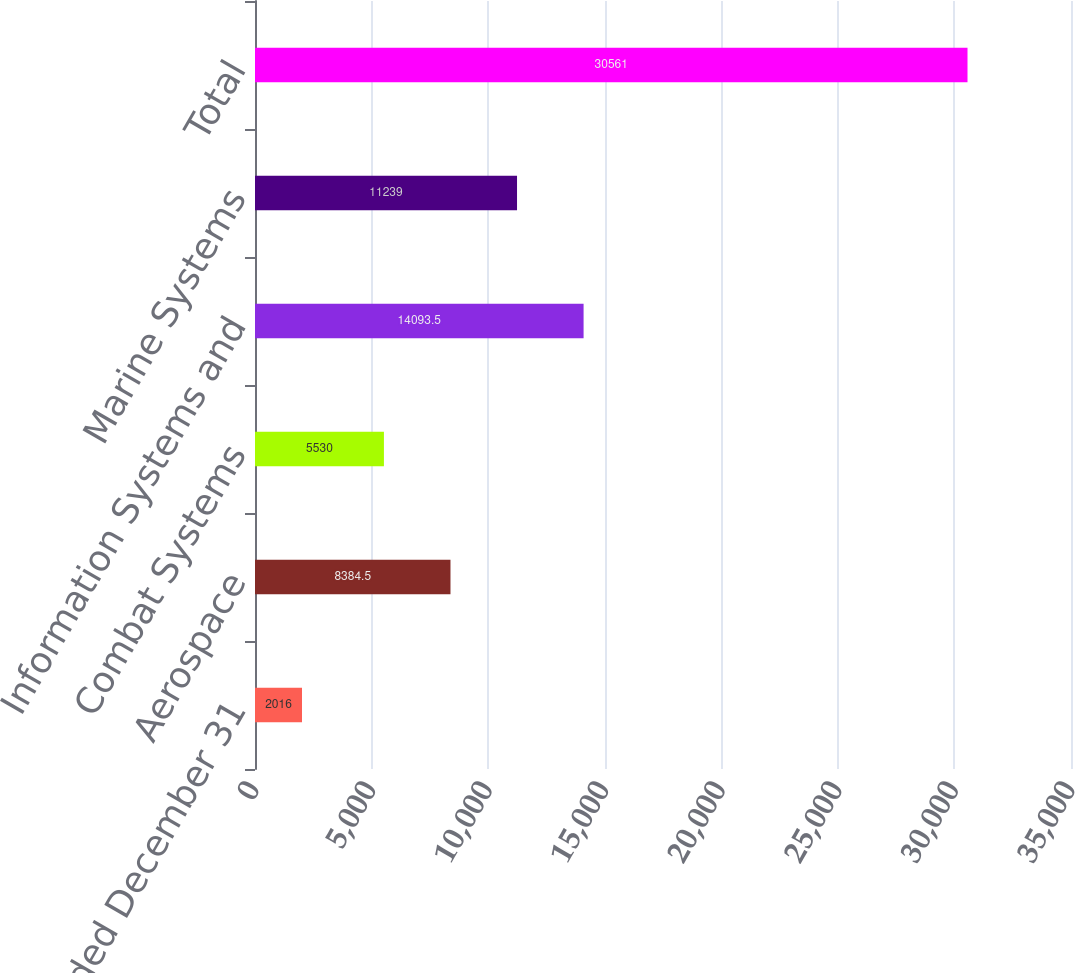<chart> <loc_0><loc_0><loc_500><loc_500><bar_chart><fcel>Year Ended December 31<fcel>Aerospace<fcel>Combat Systems<fcel>Information Systems and<fcel>Marine Systems<fcel>Total<nl><fcel>2016<fcel>8384.5<fcel>5530<fcel>14093.5<fcel>11239<fcel>30561<nl></chart> 